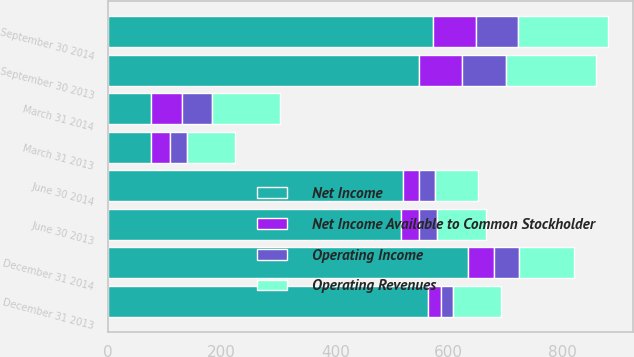<chart> <loc_0><loc_0><loc_500><loc_500><stacked_bar_chart><ecel><fcel>March 31 2014<fcel>March 31 2013<fcel>June 30 2014<fcel>June 30 2013<fcel>September 30 2014<fcel>September 30 2013<fcel>December 31 2014<fcel>December 31 2013<nl><fcel>Net Income<fcel>76<fcel>76<fcel>519<fcel>516<fcel>572<fcel>547<fcel>633<fcel>564<nl><fcel>Operating Revenues<fcel>120<fcel>85<fcel>75<fcel>87<fcel>158<fcel>158<fcel>97<fcel>85<nl><fcel>Net Income Available to Common Stockholder<fcel>54<fcel>32<fcel>29<fcel>32<fcel>75<fcel>77<fcel>46<fcel>22<nl><fcel>Operating Income<fcel>53<fcel>31<fcel>28<fcel>31<fcel>75<fcel>77<fcel>45<fcel>21<nl></chart> 